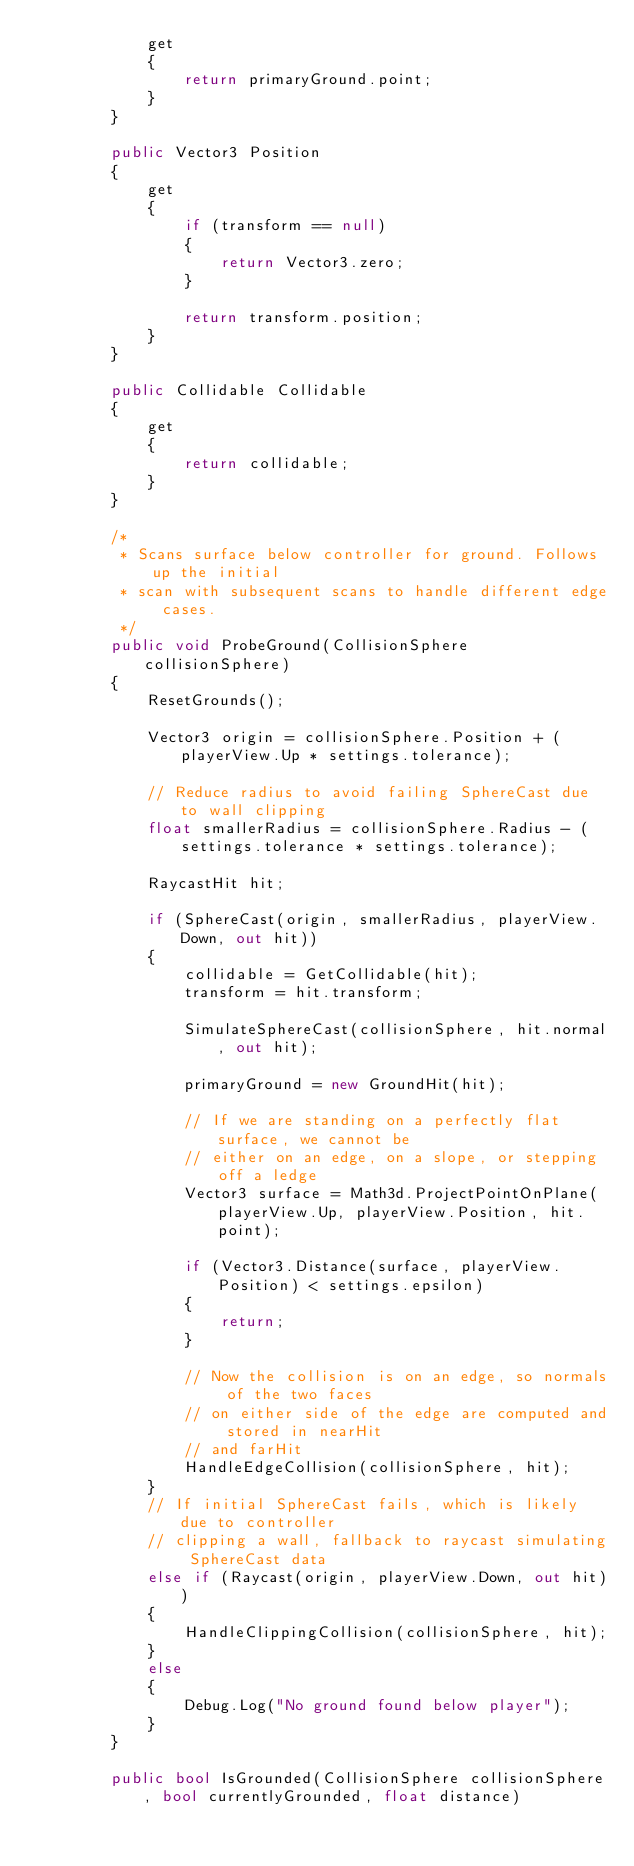<code> <loc_0><loc_0><loc_500><loc_500><_C#_>            get
            {
                return primaryGround.point;
            }
        }

        public Vector3 Position
        {
            get
            {
                if (transform == null)
                {
                    return Vector3.zero;
                }

                return transform.position;
            }
        }

        public Collidable Collidable
        {
            get
            {
                return collidable;
            }
        }

        /*
         * Scans surface below controller for ground. Follows up the initial
         * scan with subsequent scans to handle different edge cases.
         */
        public void ProbeGround(CollisionSphere collisionSphere)
        {
            ResetGrounds();

            Vector3 origin = collisionSphere.Position + (playerView.Up * settings.tolerance);

            // Reduce radius to avoid failing SphereCast due to wall clipping
            float smallerRadius = collisionSphere.Radius - (settings.tolerance * settings.tolerance);

            RaycastHit hit;

            if (SphereCast(origin, smallerRadius, playerView.Down, out hit))
            {
                collidable = GetCollidable(hit);
                transform = hit.transform;

                SimulateSphereCast(collisionSphere, hit.normal, out hit);

                primaryGround = new GroundHit(hit);

                // If we are standing on a perfectly flat surface, we cannot be
                // either on an edge, on a slope, or stepping off a ledge
                Vector3 surface = Math3d.ProjectPointOnPlane(playerView.Up, playerView.Position, hit.point);

                if (Vector3.Distance(surface, playerView.Position) < settings.epsilon)
                {
                    return;
                }

                // Now the collision is on an edge, so normals of the two faces
                // on either side of the edge are computed and stored in nearHit
                // and farHit
                HandleEdgeCollision(collisionSphere, hit);
            }
            // If initial SphereCast fails, which is likely due to controller
            // clipping a wall, fallback to raycast simulating SphereCast data
            else if (Raycast(origin, playerView.Down, out hit))
            {
                HandleClippingCollision(collisionSphere, hit);
            }
            else
            {
                Debug.Log("No ground found below player");
            }
        }

        public bool IsGrounded(CollisionSphere collisionSphere, bool currentlyGrounded, float distance)</code> 